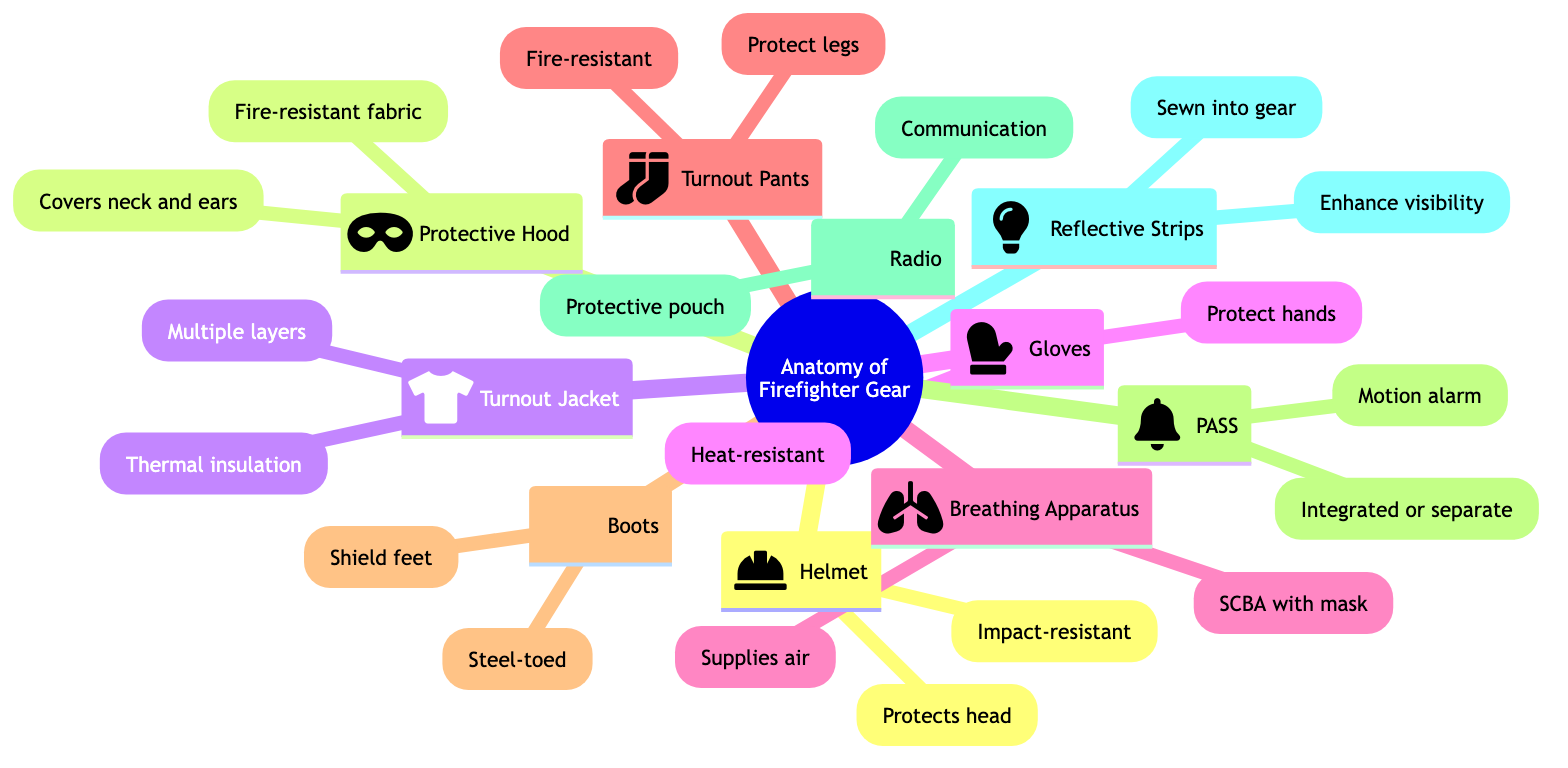What is the function of the Helmet? The diagram states that the helmet's function is to protect the head and is also impact-resistant. Thus, both points are relevant to its function.
Answer: Protects head How many components are shown in the diagram? The diagram shows 10 main components of firefighter gear. By counting each of the listed components under the root node, we find the total.
Answer: 10 What do the Reflective Strips enhance? According to the diagram, reflective strips enhance visibility, which is explicitly stated next to them as a primary function.
Answer: Visibility Which component is responsible for providing air? The diagram specifies that the Breathing Apparatus supplies air, detailed directly in its description.
Answer: Breathing Apparatus What are the functions of Turnout Pants? The diagram outlines that Turnout Pants protect legs and are fire-resistant, indicating dual functions.
Answer: Protect legs Which gear protects the hands? The diagram specifies that Gloves are responsible for protecting the hands, thus identifying them as the relevant component.
Answer: Gloves What is the purpose of the PASS? The diagram describes the PASS as a motion alarm, detailing this feature, which indicates its purpose in safety.
Answer: Motion alarm Which component includes a protective pouch? The Radio is specified in the diagram to come with a protective pouch, associating it directly with this feature.
Answer: Radio What material is the Protective Hood made of? The diagram states that the Protective Hood is made from fire-resistant fabric, directly specifying the material used.
Answer: Fire-resistant fabric List the type of toe in Boots. The diagram indicates that the Boots are steel-toed, precisely defining the type of protection they provide.
Answer: Steel-toed 